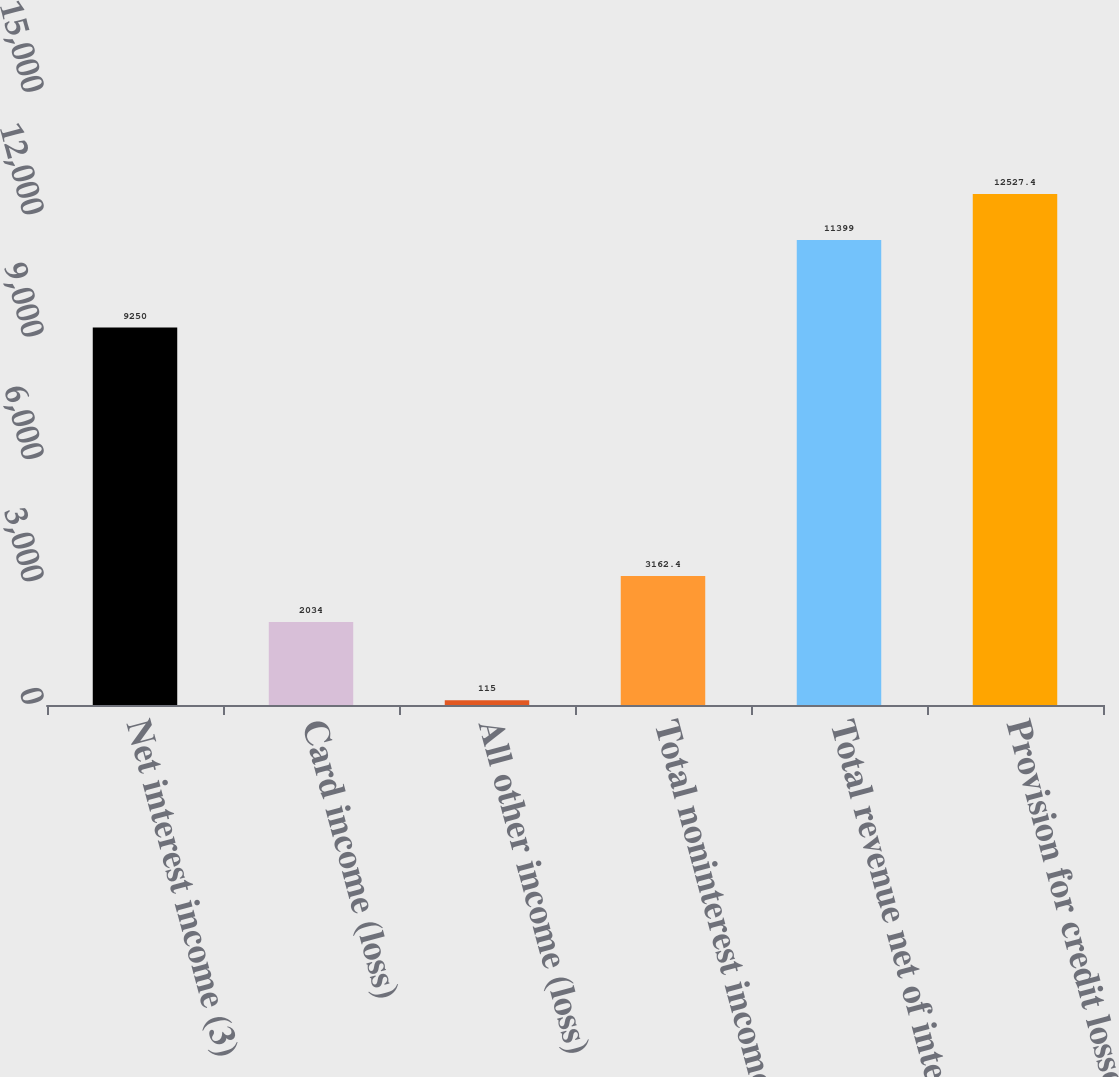<chart> <loc_0><loc_0><loc_500><loc_500><bar_chart><fcel>Net interest income (3)<fcel>Card income (loss)<fcel>All other income (loss)<fcel>Total noninterest income<fcel>Total revenue net of interest<fcel>Provision for credit losses<nl><fcel>9250<fcel>2034<fcel>115<fcel>3162.4<fcel>11399<fcel>12527.4<nl></chart> 